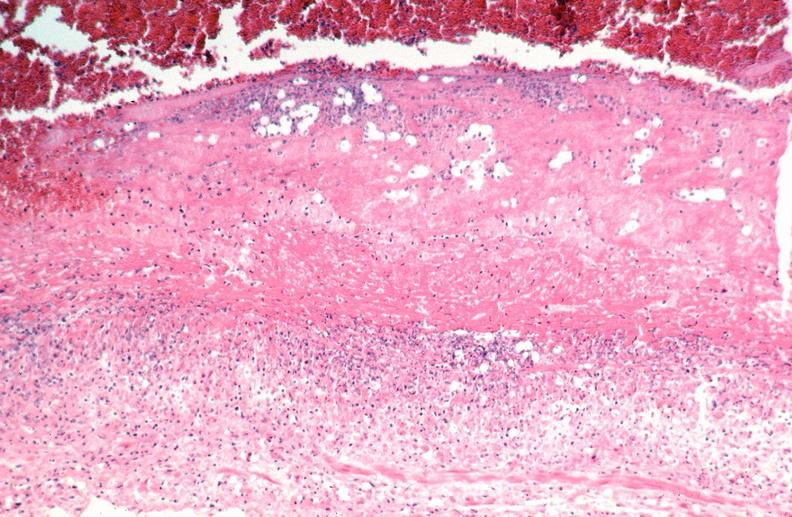what is present?
Answer the question using a single word or phrase. Vasculature 